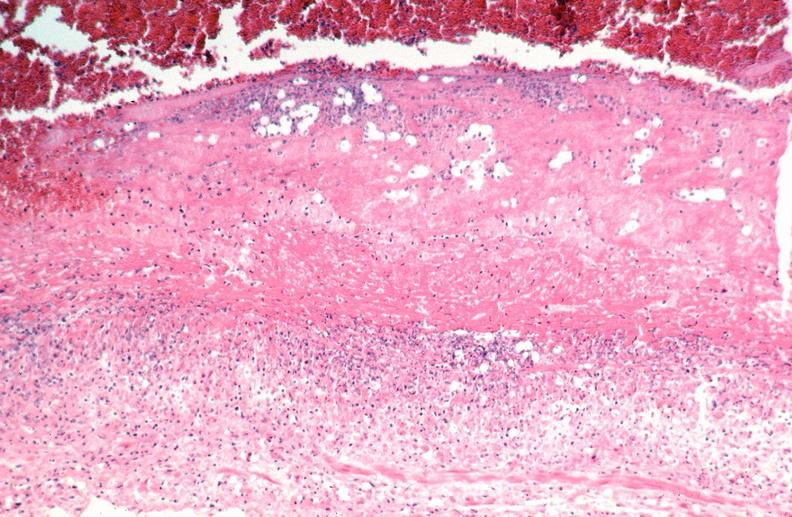what is present?
Answer the question using a single word or phrase. Vasculature 